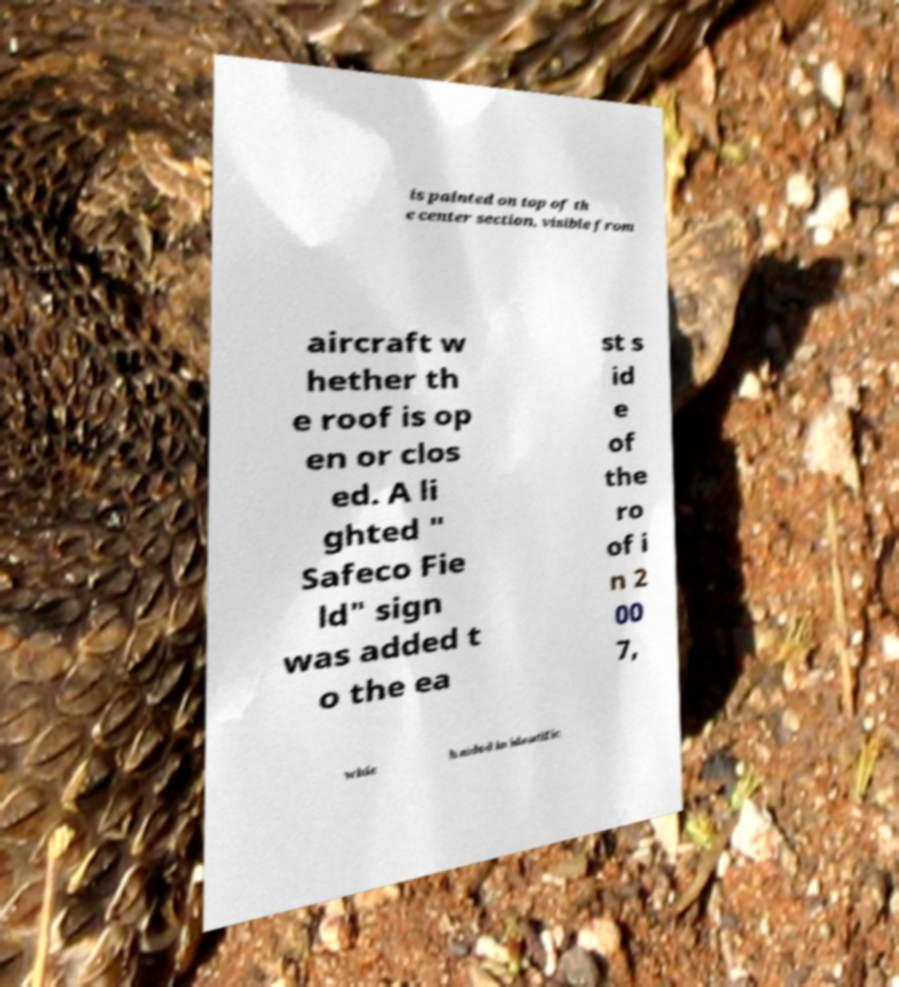Please read and relay the text visible in this image. What does it say? is painted on top of th e center section, visible from aircraft w hether th e roof is op en or clos ed. A li ghted " Safeco Fie ld" sign was added t o the ea st s id e of the ro of i n 2 00 7, whic h aided in identific 